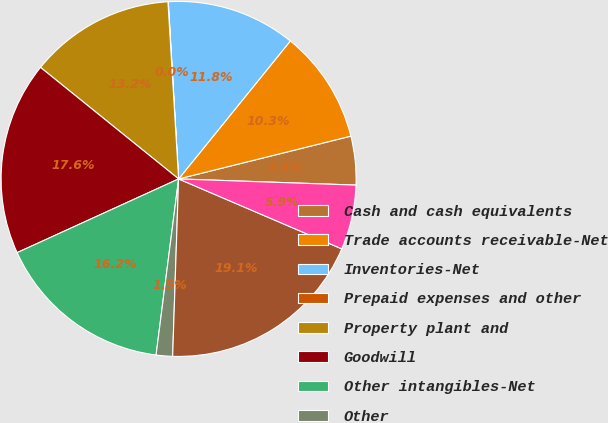<chart> <loc_0><loc_0><loc_500><loc_500><pie_chart><fcel>Cash and cash equivalents<fcel>Trade accounts receivable-Net<fcel>Inventories-Net<fcel>Prepaid expenses and other<fcel>Property plant and<fcel>Goodwill<fcel>Other intangibles-Net<fcel>Other<fcel>Total assets of discontinued<fcel>Accounts payable<nl><fcel>4.43%<fcel>10.29%<fcel>11.76%<fcel>0.03%<fcel>13.23%<fcel>17.63%<fcel>16.16%<fcel>1.49%<fcel>19.09%<fcel>5.89%<nl></chart> 